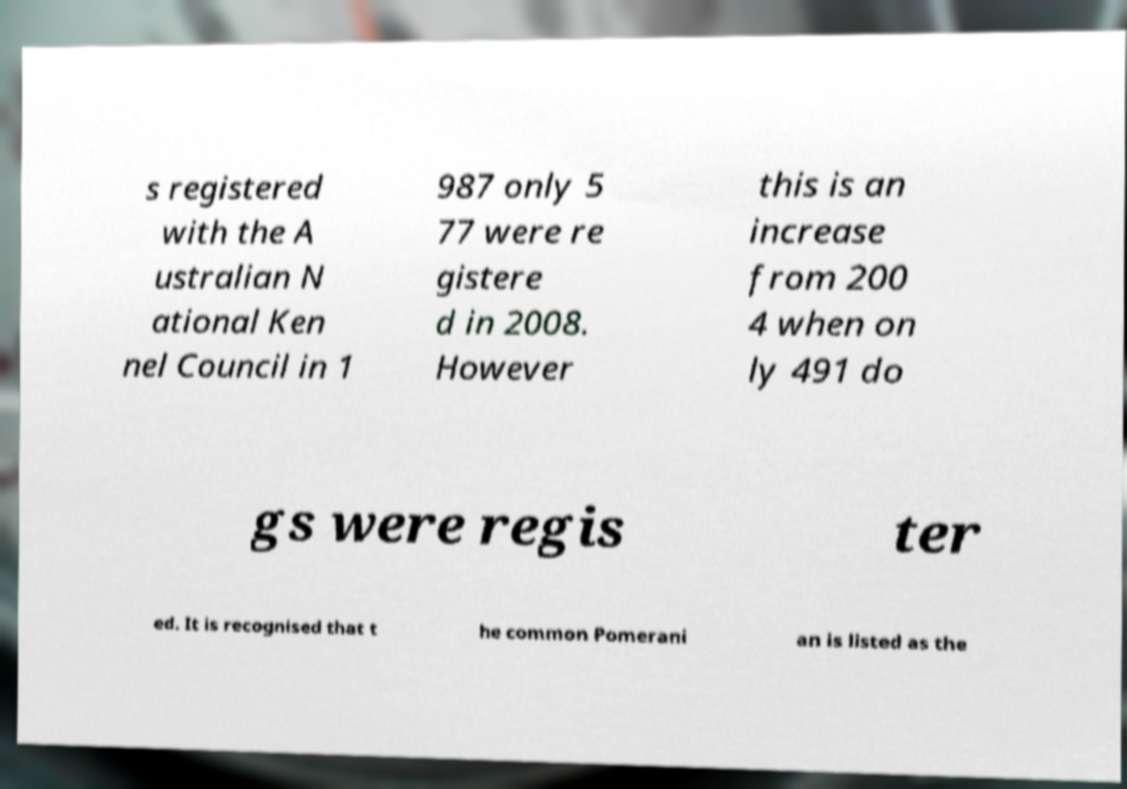Please read and relay the text visible in this image. What does it say? s registered with the A ustralian N ational Ken nel Council in 1 987 only 5 77 were re gistere d in 2008. However this is an increase from 200 4 when on ly 491 do gs were regis ter ed. It is recognised that t he common Pomerani an is listed as the 